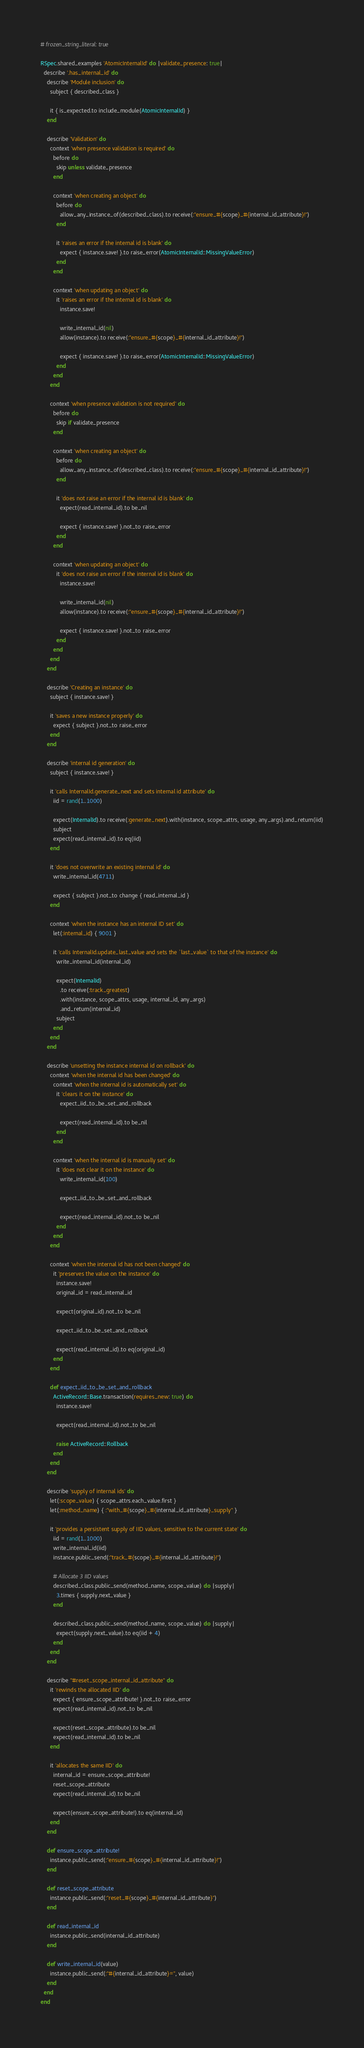<code> <loc_0><loc_0><loc_500><loc_500><_Ruby_># frozen_string_literal: true

RSpec.shared_examples 'AtomicInternalId' do |validate_presence: true|
  describe '.has_internal_id' do
    describe 'Module inclusion' do
      subject { described_class }

      it { is_expected.to include_module(AtomicInternalId) }
    end

    describe 'Validation' do
      context 'when presence validation is required' do
        before do
          skip unless validate_presence
        end

        context 'when creating an object' do
          before do
            allow_any_instance_of(described_class).to receive(:"ensure_#{scope}_#{internal_id_attribute}!")
          end

          it 'raises an error if the internal id is blank' do
            expect { instance.save! }.to raise_error(AtomicInternalId::MissingValueError)
          end
        end

        context 'when updating an object' do
          it 'raises an error if the internal id is blank' do
            instance.save!

            write_internal_id(nil)
            allow(instance).to receive(:"ensure_#{scope}_#{internal_id_attribute}!")

            expect { instance.save! }.to raise_error(AtomicInternalId::MissingValueError)
          end
        end
      end

      context 'when presence validation is not required' do
        before do
          skip if validate_presence
        end

        context 'when creating an object' do
          before do
            allow_any_instance_of(described_class).to receive(:"ensure_#{scope}_#{internal_id_attribute}!")
          end

          it 'does not raise an error if the internal id is blank' do
            expect(read_internal_id).to be_nil

            expect { instance.save! }.not_to raise_error
          end
        end

        context 'when updating an object' do
          it 'does not raise an error if the internal id is blank' do
            instance.save!

            write_internal_id(nil)
            allow(instance).to receive(:"ensure_#{scope}_#{internal_id_attribute}!")

            expect { instance.save! }.not_to raise_error
          end
        end
      end
    end

    describe 'Creating an instance' do
      subject { instance.save! }

      it 'saves a new instance properly' do
        expect { subject }.not_to raise_error
      end
    end

    describe 'internal id generation' do
      subject { instance.save! }

      it 'calls InternalId.generate_next and sets internal id attribute' do
        iid = rand(1..1000)

        expect(InternalId).to receive(:generate_next).with(instance, scope_attrs, usage, any_args).and_return(iid)
        subject
        expect(read_internal_id).to eq(iid)
      end

      it 'does not overwrite an existing internal id' do
        write_internal_id(4711)

        expect { subject }.not_to change { read_internal_id }
      end

      context 'when the instance has an internal ID set' do
        let(:internal_id) { 9001 }

        it 'calls InternalId.update_last_value and sets the `last_value` to that of the instance' do
          write_internal_id(internal_id)

          expect(InternalId)
            .to receive(:track_greatest)
            .with(instance, scope_attrs, usage, internal_id, any_args)
            .and_return(internal_id)
          subject
        end
      end
    end

    describe 'unsetting the instance internal id on rollback' do
      context 'when the internal id has been changed' do
        context 'when the internal id is automatically set' do
          it 'clears it on the instance' do
            expect_iid_to_be_set_and_rollback

            expect(read_internal_id).to be_nil
          end
        end

        context 'when the internal id is manually set' do
          it 'does not clear it on the instance' do
            write_internal_id(100)

            expect_iid_to_be_set_and_rollback

            expect(read_internal_id).not_to be_nil
          end
        end
      end

      context 'when the internal id has not been changed' do
        it 'preserves the value on the instance' do
          instance.save!
          original_id = read_internal_id

          expect(original_id).not_to be_nil

          expect_iid_to_be_set_and_rollback

          expect(read_internal_id).to eq(original_id)
        end
      end

      def expect_iid_to_be_set_and_rollback
        ActiveRecord::Base.transaction(requires_new: true) do
          instance.save!

          expect(read_internal_id).not_to be_nil

          raise ActiveRecord::Rollback
        end
      end
    end

    describe 'supply of internal ids' do
      let(:scope_value) { scope_attrs.each_value.first }
      let(:method_name) { :"with_#{scope}_#{internal_id_attribute}_supply" }

      it 'provides a persistent supply of IID values, sensitive to the current state' do
        iid = rand(1..1000)
        write_internal_id(iid)
        instance.public_send(:"track_#{scope}_#{internal_id_attribute}!")

        # Allocate 3 IID values
        described_class.public_send(method_name, scope_value) do |supply|
          3.times { supply.next_value }
        end

        described_class.public_send(method_name, scope_value) do |supply|
          expect(supply.next_value).to eq(iid + 4)
        end
      end
    end

    describe "#reset_scope_internal_id_attribute" do
      it 'rewinds the allocated IID' do
        expect { ensure_scope_attribute! }.not_to raise_error
        expect(read_internal_id).not_to be_nil

        expect(reset_scope_attribute).to be_nil
        expect(read_internal_id).to be_nil
      end

      it 'allocates the same IID' do
        internal_id = ensure_scope_attribute!
        reset_scope_attribute
        expect(read_internal_id).to be_nil

        expect(ensure_scope_attribute!).to eq(internal_id)
      end
    end

    def ensure_scope_attribute!
      instance.public_send(:"ensure_#{scope}_#{internal_id_attribute}!")
    end

    def reset_scope_attribute
      instance.public_send(:"reset_#{scope}_#{internal_id_attribute}")
    end

    def read_internal_id
      instance.public_send(internal_id_attribute)
    end

    def write_internal_id(value)
      instance.public_send(:"#{internal_id_attribute}=", value)
    end
  end
end
</code> 